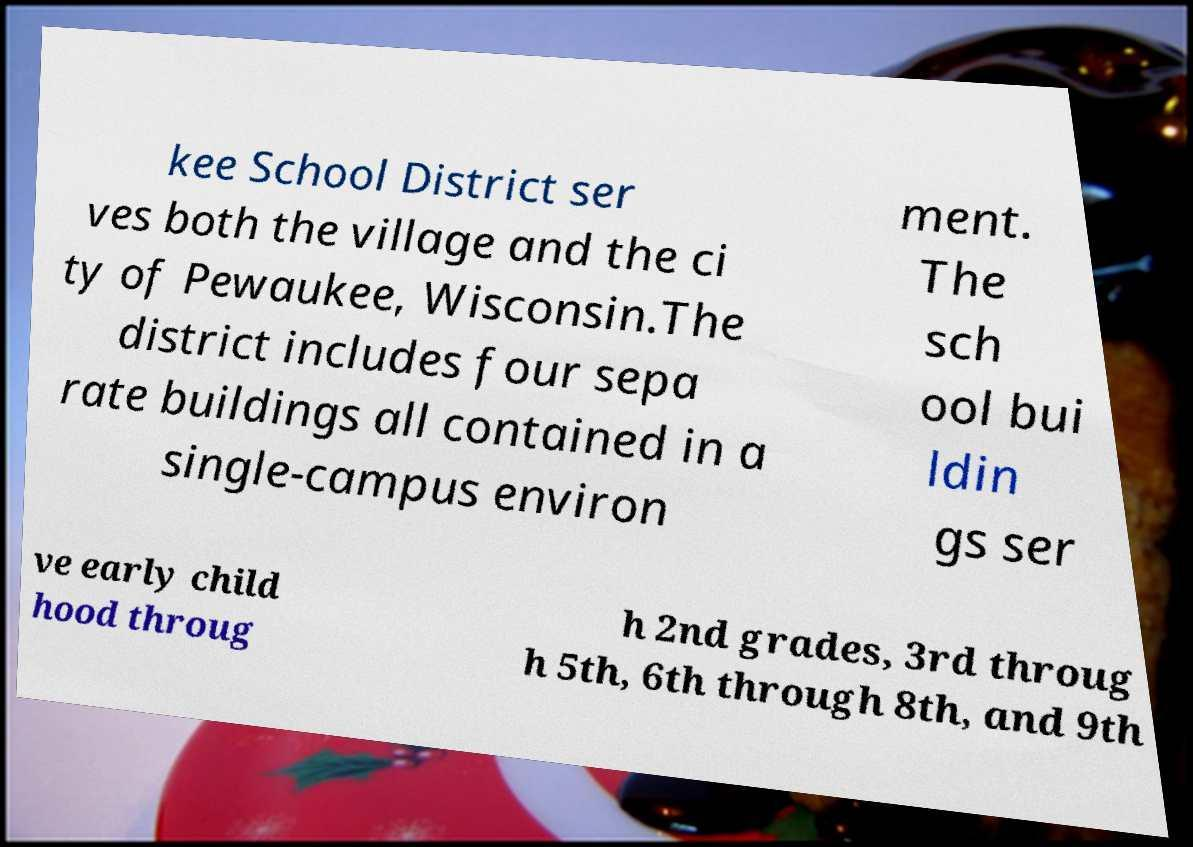Please read and relay the text visible in this image. What does it say? kee School District ser ves both the village and the ci ty of Pewaukee, Wisconsin.The district includes four sepa rate buildings all contained in a single-campus environ ment. The sch ool bui ldin gs ser ve early child hood throug h 2nd grades, 3rd throug h 5th, 6th through 8th, and 9th 